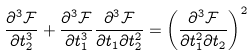<formula> <loc_0><loc_0><loc_500><loc_500>\frac { \partial ^ { 3 } \mathcal { F } } { \partial t _ { 2 } ^ { 3 } } + \frac { \partial ^ { 3 } \mathcal { F } } { \partial t _ { 1 } ^ { 3 } } \frac { \partial ^ { 3 } \mathcal { F } } { \partial t _ { 1 } \partial t _ { 2 } ^ { 2 } } = \left ( \frac { \partial ^ { 3 } \mathcal { F } } { \partial t _ { 1 } ^ { 2 } \partial t _ { 2 } } \right ) ^ { 2 }</formula> 